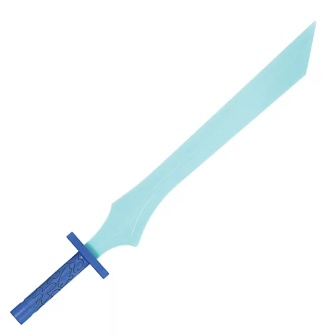What might be the historical inspiration for this sword's design? The toy sword's design appears to draw inspiration from medieval European swords, known for their crossguards and tapered blades. The elegant floral design on the pommel might be a nod to the intricate craftsmanship often seen in historical artifacts, showcasing a blend of functionality and artistry. The slight curve of the blade could hint at influence from Eastern swords, such as the scimitar, which were known for their curved design and proficient cutting ability. 